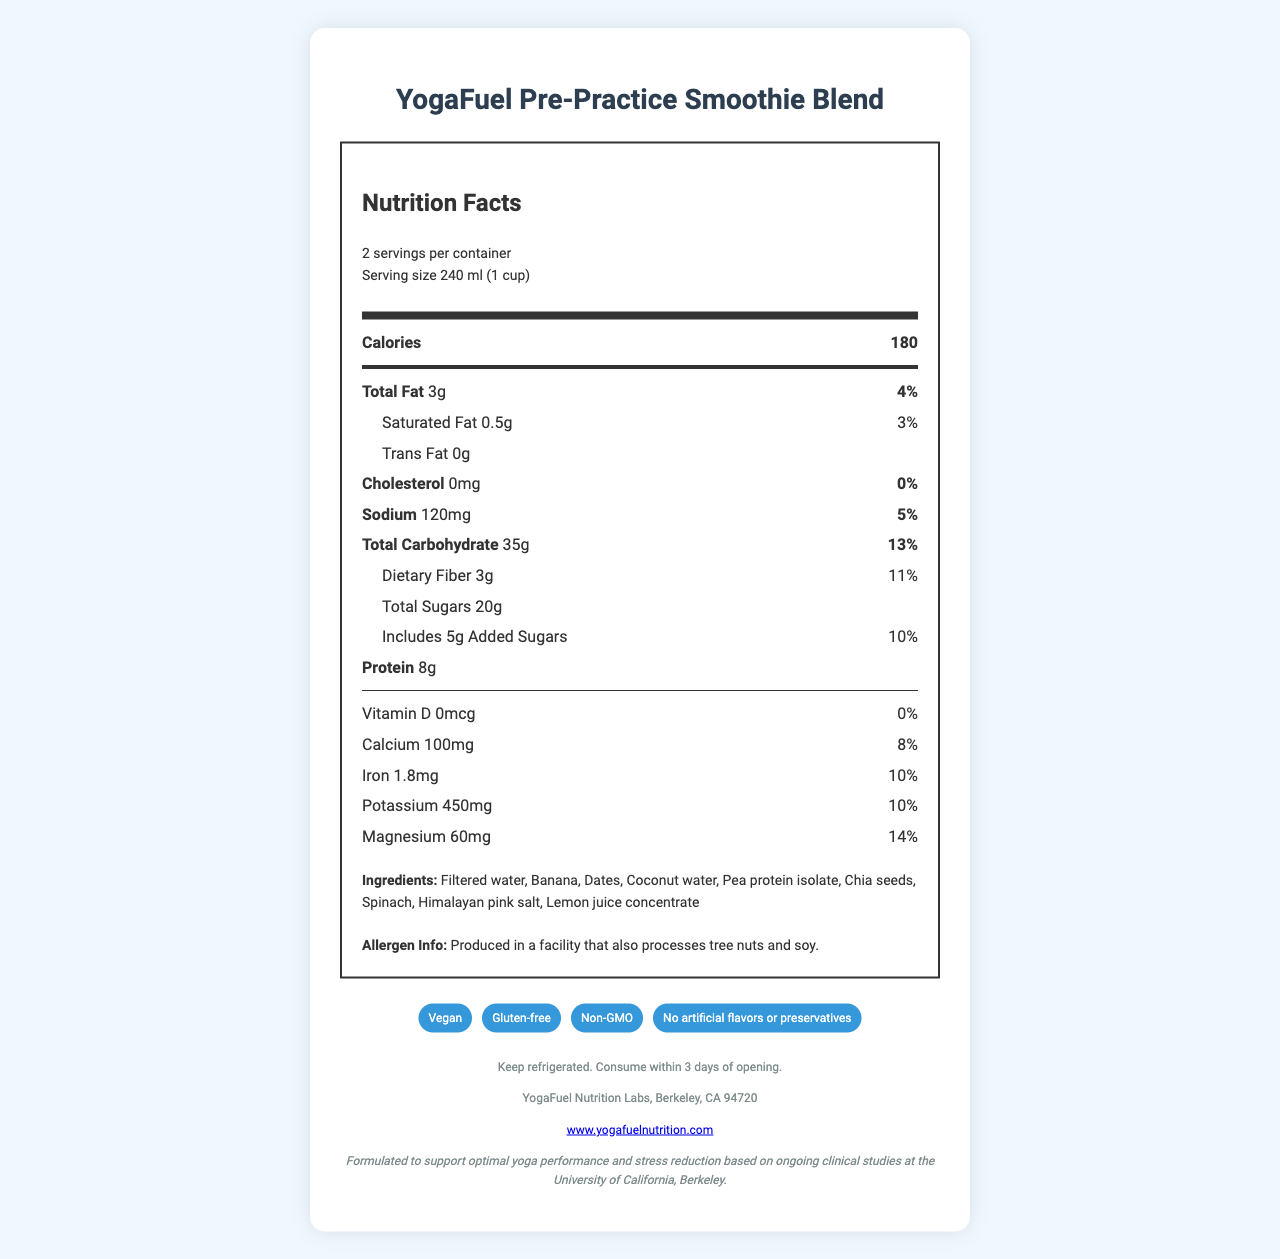what is the serving size? The nutrition label states that the serving size is 240 ml (1 cup).
Answer: 240 ml (1 cup) how many servings are in the container? The document mentions that there are 2 servings per container.
Answer: 2 how many calories are in each serving? The nutrition label lists 180 calories per serving.
Answer: 180 how many grams of protein are in a serving? The label indicates that each serving contains 8 grams of protein.
Answer: 8g what is the amount of sodium per serving? According to the label, the amount of sodium per serving is 120mg.
Answer: 120mg what are the three main ingredients in the smoothie? A. Banana, Dates, Coconut water B. Apple, Orange, Spinach C. Mango, Pineapple, Coconut milk The ingredients list shows that the first three ingredients are Banana, Dates, and Coconut water.
Answer: A. Banana, Dates, Coconut water which of the following nutrients has the highest daily value percentage? A. Sodium B. Magnesium C. Iron D. Dietary Fiber Magnesium has a daily value percentage of 14%, which is higher than the other listed nutrients.
Answer: B. Magnesium does the product contain added sugars? The label shows that the product contains 5g of added sugars.
Answer: Yes is the product gluten-free? The claims section states that the product is gluten-free.
Answer: Yes summarize the document in one sentence. The document details the nutrition facts, ingredients, claims, and storage instructions of the YogaFuel Pre-Practice Smoothie Blend, noting its formulation for yoga and stress reduction.
Answer: The document is a nutrition facts label for YogaFuel Pre-Practice Smoothie Blend, listing its nutritional content, ingredients, claims, and storage instructions, emphasizing its formulation for yoga performance and stress reduction. does the product contain any artificial flavors or preservatives? The claims section mentions that the product contains no artificial flavors or preservatives.
Answer: No how much potassium is in a serving? The nutrition label indicates there are 450mg of potassium per serving.
Answer: 450mg what is the daily value percentage of dietary fiber? The label lists the daily value percentage of dietary fiber as 11%.
Answer: 11% what type of facility is the product produced in? The allergen information states that the product is produced in a facility that processes tree nuts and soy.
Answer: Produced in a facility that also processes tree nuts and soy how many grams of total sugars are in a serving? The label indicates that there are 20 grams of total sugars per serving.
Answer: 20g how does the product support yoga performance and stress reduction? The document mentions that the product is formulated to support optimal yoga performance and stress reduction based on ongoing clinical studies, but does not provide specific details on how it does so.
Answer: I don't know 